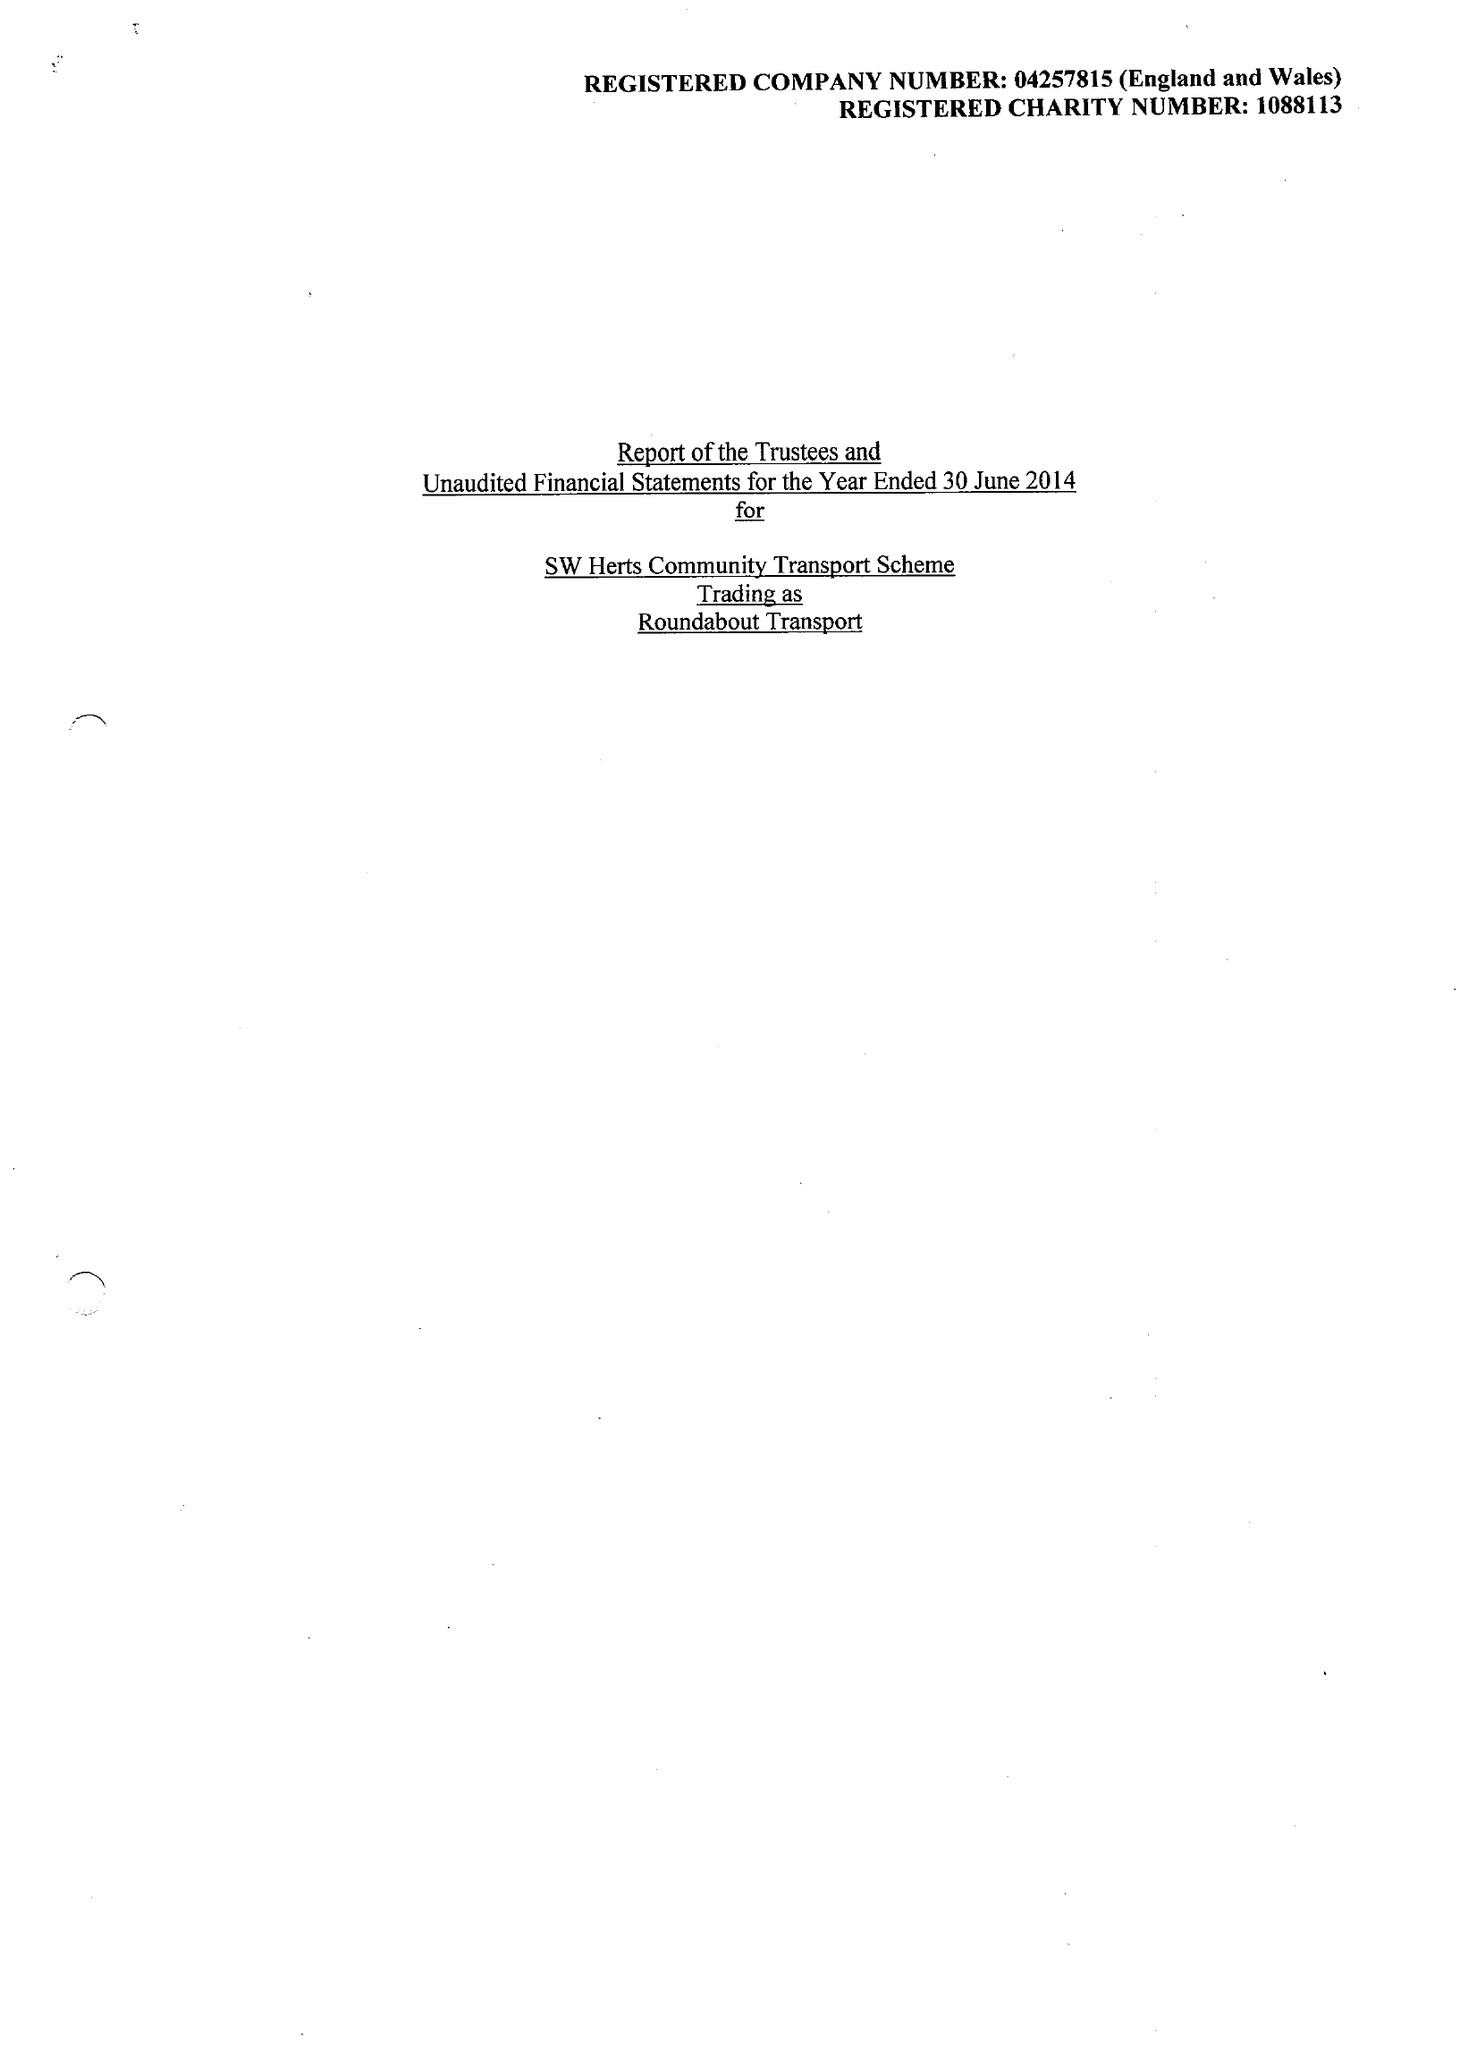What is the value for the income_annually_in_british_pounds?
Answer the question using a single word or phrase. 143634.00 